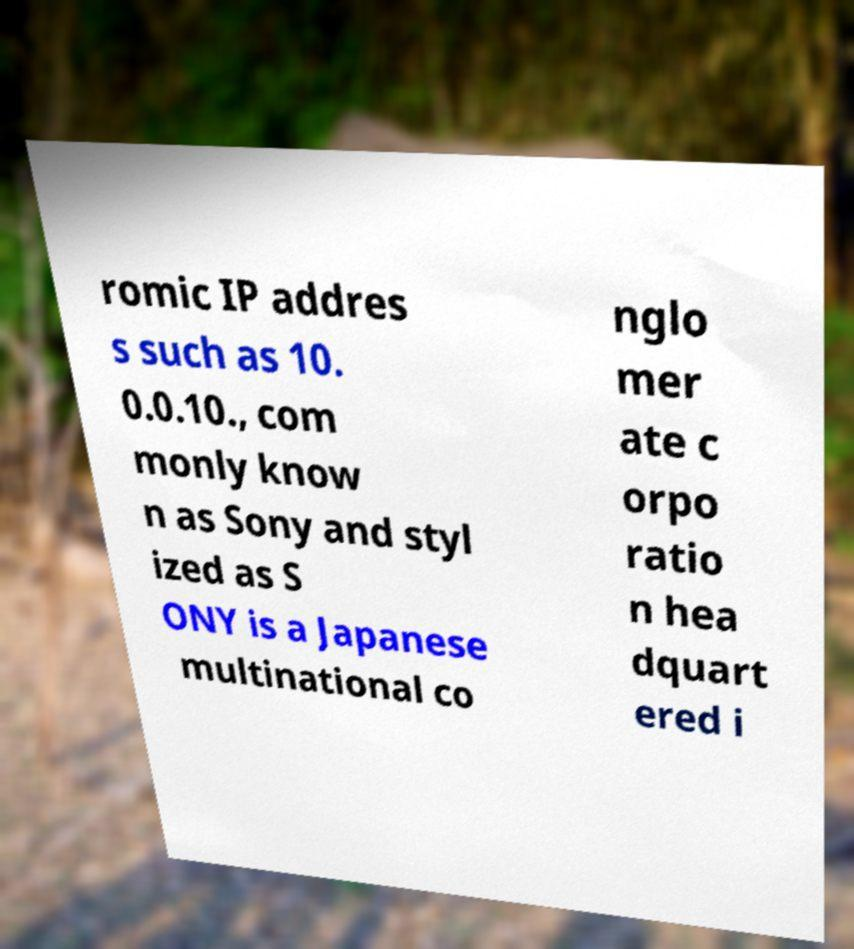Could you assist in decoding the text presented in this image and type it out clearly? romic IP addres s such as 10. 0.0.10., com monly know n as Sony and styl ized as S ONY is a Japanese multinational co nglo mer ate c orpo ratio n hea dquart ered i 